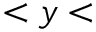Convert formula to latex. <formula><loc_0><loc_0><loc_500><loc_500>< y <</formula> 